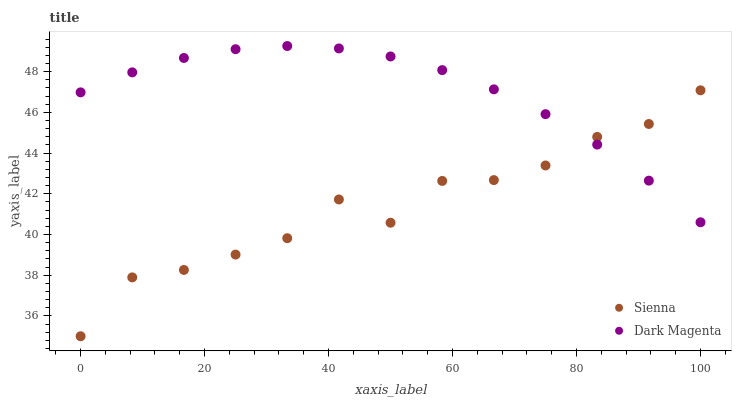Does Sienna have the minimum area under the curve?
Answer yes or no. Yes. Does Dark Magenta have the maximum area under the curve?
Answer yes or no. Yes. Does Dark Magenta have the minimum area under the curve?
Answer yes or no. No. Is Dark Magenta the smoothest?
Answer yes or no. Yes. Is Sienna the roughest?
Answer yes or no. Yes. Is Dark Magenta the roughest?
Answer yes or no. No. Does Sienna have the lowest value?
Answer yes or no. Yes. Does Dark Magenta have the lowest value?
Answer yes or no. No. Does Dark Magenta have the highest value?
Answer yes or no. Yes. Does Dark Magenta intersect Sienna?
Answer yes or no. Yes. Is Dark Magenta less than Sienna?
Answer yes or no. No. Is Dark Magenta greater than Sienna?
Answer yes or no. No. 